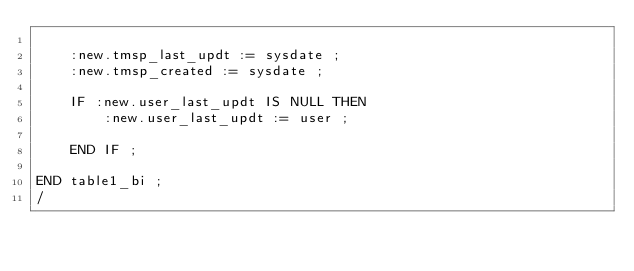Convert code to text. <code><loc_0><loc_0><loc_500><loc_500><_SQL_>
    :new.tmsp_last_updt := sysdate ;
    :new.tmsp_created := sysdate ;

    IF :new.user_last_updt IS NULL THEN
        :new.user_last_updt := user ;

    END IF ;

END table1_bi ;
/
</code> 